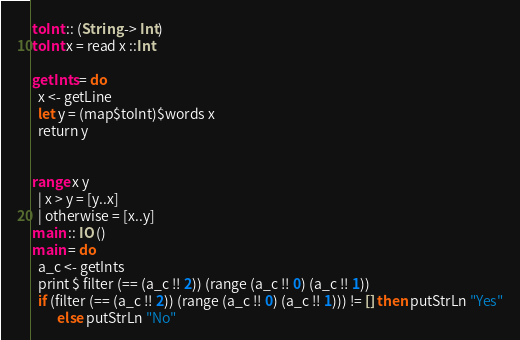<code> <loc_0><loc_0><loc_500><loc_500><_Haskell_>toInt :: (String -> Int)
toInt x = read x ::Int

getInts = do
  x <- getLine
  let y = (map$toInt)$words x
  return y


range x y
  | x > y = [y..x]
  | otherwise = [x..y]
main :: IO ()
main = do
  a_c <- getInts
  print $ filter (== (a_c !! 2)) (range (a_c !! 0) (a_c !! 1))
  if (filter (== (a_c !! 2)) (range (a_c !! 0) (a_c !! 1))) != [] then putStrLn "Yes"
        else putStrLn "No"
</code> 